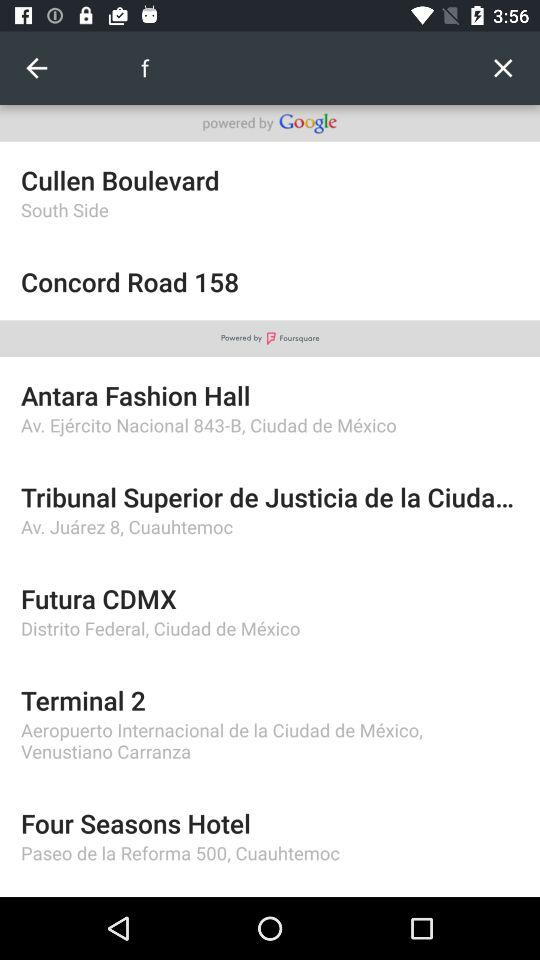Which city contains Cullen Boulevard?
When the provided information is insufficient, respond with <no answer>. <no answer> 